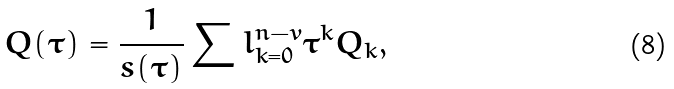Convert formula to latex. <formula><loc_0><loc_0><loc_500><loc_500>Q ( \tau ) = \frac { 1 } { s ( \tau ) } \sum l ^ { n - v } _ { k = 0 } { \tau } ^ { k } Q _ { k } ,</formula> 